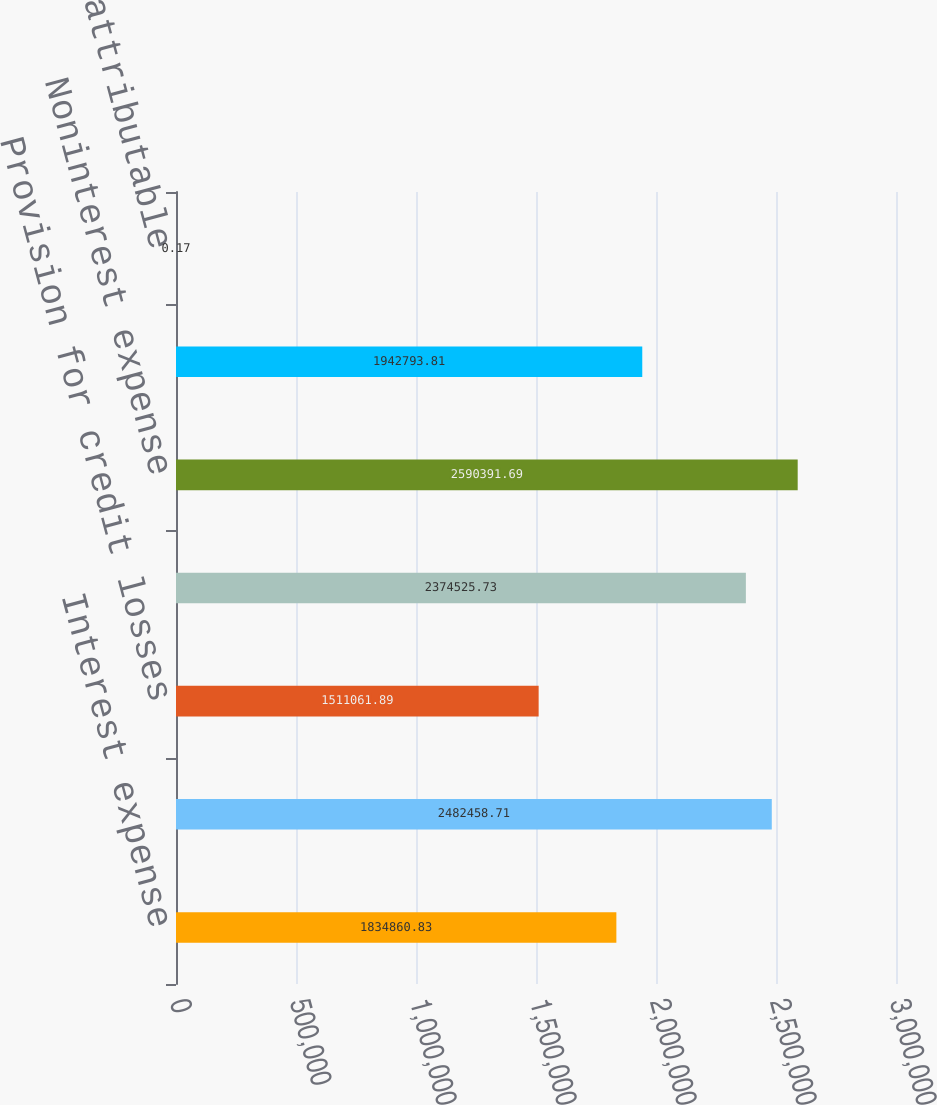<chart> <loc_0><loc_0><loc_500><loc_500><bar_chart><fcel>Interest expense<fcel>Net interest income<fcel>Provision for credit losses<fcel>Noninterest income<fcel>Noninterest expense<fcel>Income (loss) from continuing<fcel>Net income (loss) attributable<nl><fcel>1.83486e+06<fcel>2.48246e+06<fcel>1.51106e+06<fcel>2.37453e+06<fcel>2.59039e+06<fcel>1.94279e+06<fcel>0.17<nl></chart> 